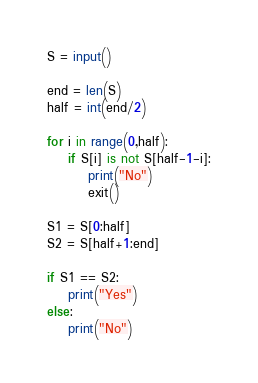<code> <loc_0><loc_0><loc_500><loc_500><_Python_>S = input()

end = len(S)
half = int(end/2)

for i in range(0,half):
    if S[i] is not S[half-1-i]:
        print("No")
        exit()
        
S1 = S[0:half]
S2 = S[half+1:end]

if S1 == S2:
    print("Yes")
else:
    print("No")</code> 